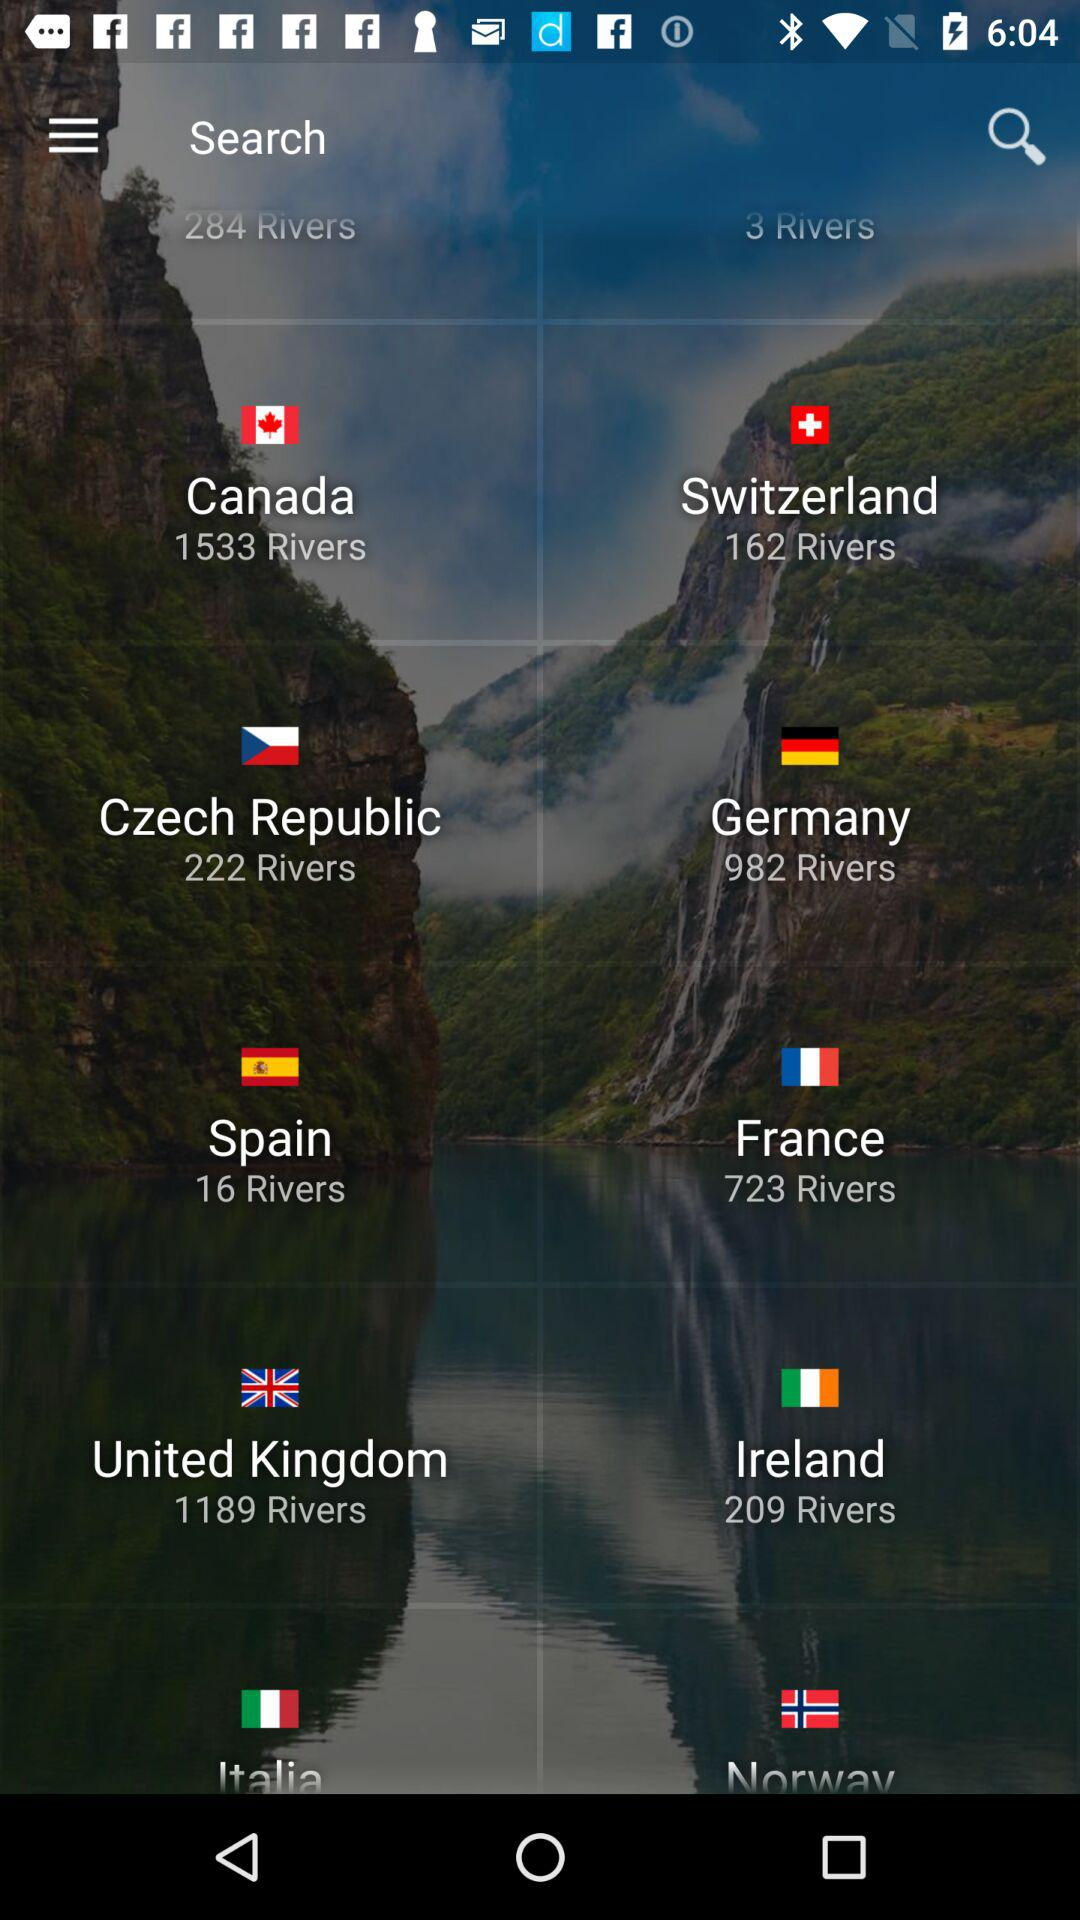How many rivers does Italia have?
When the provided information is insufficient, respond with <no answer>. <no answer> 